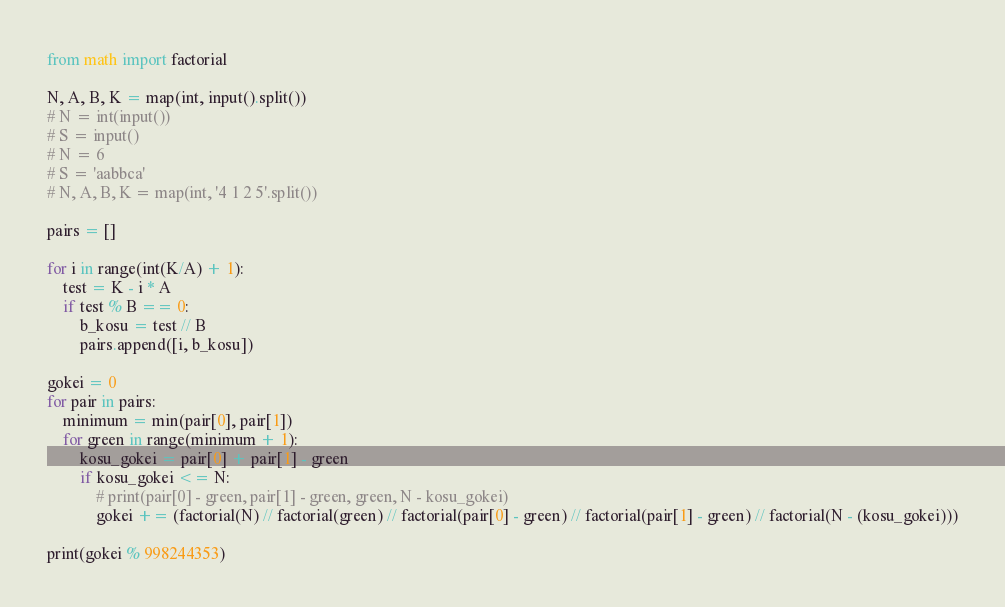Convert code to text. <code><loc_0><loc_0><loc_500><loc_500><_Python_>from math import factorial

N, A, B, K = map(int, input().split())
# N = int(input())
# S = input()
# N = 6
# S = 'aabbca'
# N, A, B, K = map(int, '4 1 2 5'.split())

pairs = []

for i in range(int(K/A) + 1):
    test = K - i * A
    if test % B == 0:
        b_kosu = test // B
        pairs.append([i, b_kosu])

gokei = 0
for pair in pairs:
    minimum = min(pair[0], pair[1])
    for green in range(minimum + 1):
        kosu_gokei = pair[0] + pair[1] - green
        if kosu_gokei <= N:
            # print(pair[0] - green, pair[1] - green, green, N - kosu_gokei)
            gokei += (factorial(N) // factorial(green) // factorial(pair[0] - green) // factorial(pair[1] - green) // factorial(N - (kosu_gokei)))

print(gokei % 998244353)
</code> 